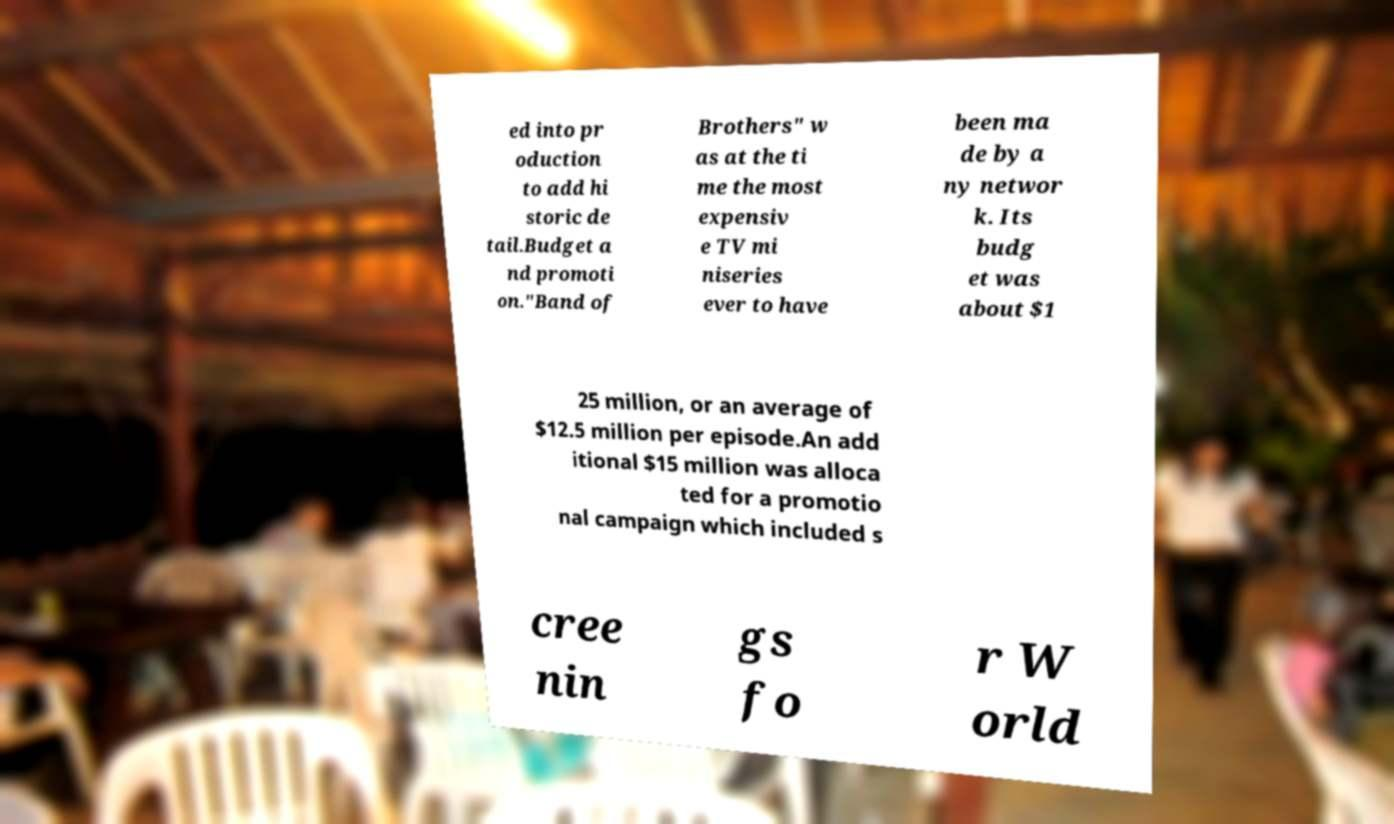Can you accurately transcribe the text from the provided image for me? ed into pr oduction to add hi storic de tail.Budget a nd promoti on."Band of Brothers" w as at the ti me the most expensiv e TV mi niseries ever to have been ma de by a ny networ k. Its budg et was about $1 25 million, or an average of $12.5 million per episode.An add itional $15 million was alloca ted for a promotio nal campaign which included s cree nin gs fo r W orld 